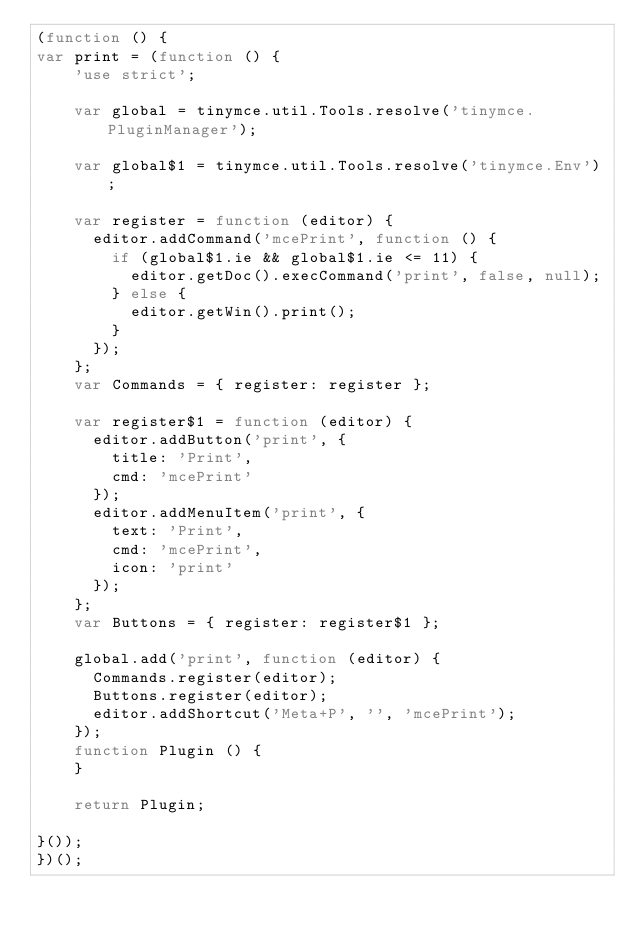<code> <loc_0><loc_0><loc_500><loc_500><_JavaScript_>(function () {
var print = (function () {
    'use strict';

    var global = tinymce.util.Tools.resolve('tinymce.PluginManager');

    var global$1 = tinymce.util.Tools.resolve('tinymce.Env');

    var register = function (editor) {
      editor.addCommand('mcePrint', function () {
        if (global$1.ie && global$1.ie <= 11) {
          editor.getDoc().execCommand('print', false, null);
        } else {
          editor.getWin().print();
        }
      });
    };
    var Commands = { register: register };

    var register$1 = function (editor) {
      editor.addButton('print', {
        title: 'Print',
        cmd: 'mcePrint'
      });
      editor.addMenuItem('print', {
        text: 'Print',
        cmd: 'mcePrint',
        icon: 'print'
      });
    };
    var Buttons = { register: register$1 };

    global.add('print', function (editor) {
      Commands.register(editor);
      Buttons.register(editor);
      editor.addShortcut('Meta+P', '', 'mcePrint');
    });
    function Plugin () {
    }

    return Plugin;

}());
})();
</code> 